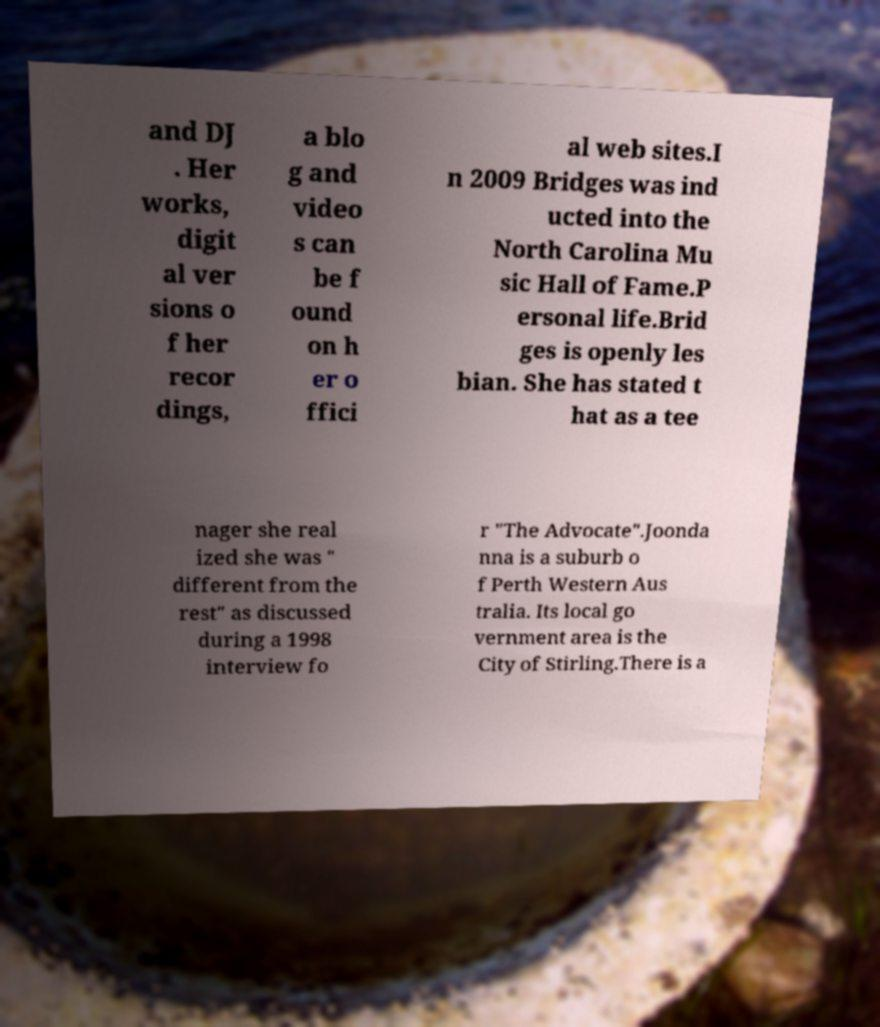What messages or text are displayed in this image? I need them in a readable, typed format. and DJ . Her works, digit al ver sions o f her recor dings, a blo g and video s can be f ound on h er o ffici al web sites.I n 2009 Bridges was ind ucted into the North Carolina Mu sic Hall of Fame.P ersonal life.Brid ges is openly les bian. She has stated t hat as a tee nager she real ized she was " different from the rest" as discussed during a 1998 interview fo r "The Advocate".Joonda nna is a suburb o f Perth Western Aus tralia. Its local go vernment area is the City of Stirling.There is a 